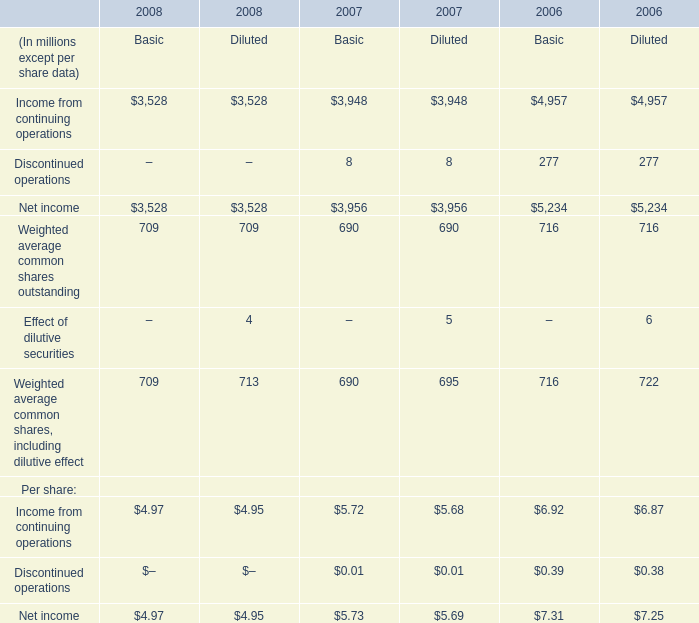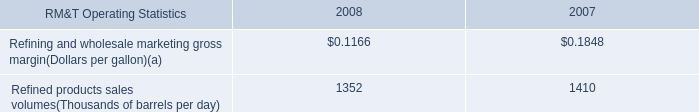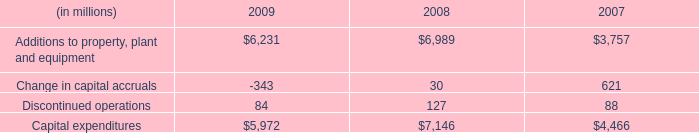In what year is Net income for Basic greater than 5000? 
Answer: 2006. 